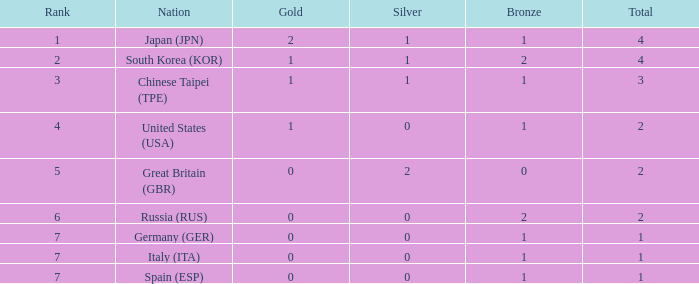What is the standing of the country having more than 2 medals, and 2 gold medals? 1.0. 